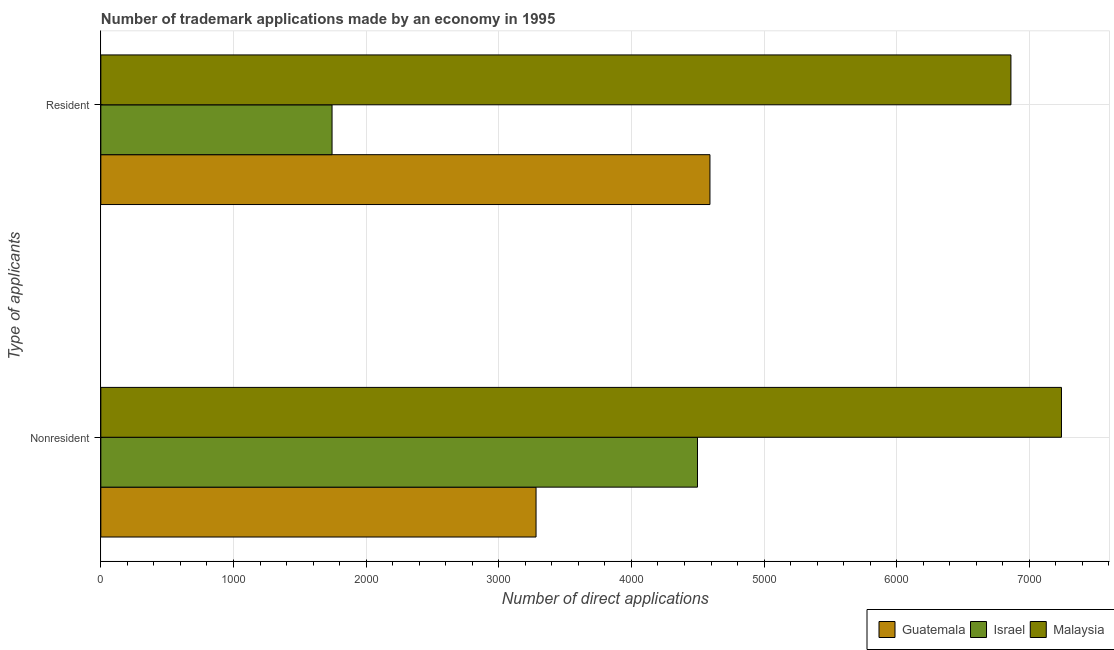Are the number of bars on each tick of the Y-axis equal?
Provide a short and direct response. Yes. How many bars are there on the 1st tick from the bottom?
Ensure brevity in your answer.  3. What is the label of the 1st group of bars from the top?
Provide a succinct answer. Resident. What is the number of trademark applications made by non residents in Malaysia?
Your response must be concise. 7242. Across all countries, what is the maximum number of trademark applications made by non residents?
Your answer should be compact. 7242. Across all countries, what is the minimum number of trademark applications made by residents?
Make the answer very short. 1743. In which country was the number of trademark applications made by residents maximum?
Give a very brief answer. Malaysia. In which country was the number of trademark applications made by residents minimum?
Give a very brief answer. Israel. What is the total number of trademark applications made by residents in the graph?
Your answer should be very brief. 1.32e+04. What is the difference between the number of trademark applications made by non residents in Israel and that in Malaysia?
Offer a terse response. -2744. What is the difference between the number of trademark applications made by residents in Guatemala and the number of trademark applications made by non residents in Israel?
Keep it short and to the point. 94. What is the average number of trademark applications made by non residents per country?
Your response must be concise. 5007. What is the difference between the number of trademark applications made by residents and number of trademark applications made by non residents in Israel?
Provide a short and direct response. -2755. What is the ratio of the number of trademark applications made by non residents in Guatemala to that in Malaysia?
Provide a short and direct response. 0.45. What does the 2nd bar from the bottom in Resident represents?
Keep it short and to the point. Israel. Are all the bars in the graph horizontal?
Your response must be concise. Yes. Are the values on the major ticks of X-axis written in scientific E-notation?
Keep it short and to the point. No. Where does the legend appear in the graph?
Keep it short and to the point. Bottom right. How are the legend labels stacked?
Your response must be concise. Horizontal. What is the title of the graph?
Give a very brief answer. Number of trademark applications made by an economy in 1995. Does "Sub-Saharan Africa (all income levels)" appear as one of the legend labels in the graph?
Make the answer very short. No. What is the label or title of the X-axis?
Ensure brevity in your answer.  Number of direct applications. What is the label or title of the Y-axis?
Ensure brevity in your answer.  Type of applicants. What is the Number of direct applications of Guatemala in Nonresident?
Your answer should be very brief. 3281. What is the Number of direct applications in Israel in Nonresident?
Offer a very short reply. 4498. What is the Number of direct applications in Malaysia in Nonresident?
Provide a short and direct response. 7242. What is the Number of direct applications in Guatemala in Resident?
Provide a succinct answer. 4592. What is the Number of direct applications of Israel in Resident?
Offer a very short reply. 1743. What is the Number of direct applications in Malaysia in Resident?
Keep it short and to the point. 6861. Across all Type of applicants, what is the maximum Number of direct applications of Guatemala?
Provide a short and direct response. 4592. Across all Type of applicants, what is the maximum Number of direct applications in Israel?
Your response must be concise. 4498. Across all Type of applicants, what is the maximum Number of direct applications in Malaysia?
Provide a short and direct response. 7242. Across all Type of applicants, what is the minimum Number of direct applications of Guatemala?
Make the answer very short. 3281. Across all Type of applicants, what is the minimum Number of direct applications in Israel?
Offer a terse response. 1743. Across all Type of applicants, what is the minimum Number of direct applications in Malaysia?
Your response must be concise. 6861. What is the total Number of direct applications in Guatemala in the graph?
Your answer should be very brief. 7873. What is the total Number of direct applications of Israel in the graph?
Make the answer very short. 6241. What is the total Number of direct applications in Malaysia in the graph?
Make the answer very short. 1.41e+04. What is the difference between the Number of direct applications of Guatemala in Nonresident and that in Resident?
Provide a succinct answer. -1311. What is the difference between the Number of direct applications of Israel in Nonresident and that in Resident?
Give a very brief answer. 2755. What is the difference between the Number of direct applications in Malaysia in Nonresident and that in Resident?
Give a very brief answer. 381. What is the difference between the Number of direct applications of Guatemala in Nonresident and the Number of direct applications of Israel in Resident?
Provide a short and direct response. 1538. What is the difference between the Number of direct applications of Guatemala in Nonresident and the Number of direct applications of Malaysia in Resident?
Your answer should be compact. -3580. What is the difference between the Number of direct applications in Israel in Nonresident and the Number of direct applications in Malaysia in Resident?
Your answer should be very brief. -2363. What is the average Number of direct applications in Guatemala per Type of applicants?
Provide a short and direct response. 3936.5. What is the average Number of direct applications in Israel per Type of applicants?
Offer a terse response. 3120.5. What is the average Number of direct applications of Malaysia per Type of applicants?
Make the answer very short. 7051.5. What is the difference between the Number of direct applications of Guatemala and Number of direct applications of Israel in Nonresident?
Provide a short and direct response. -1217. What is the difference between the Number of direct applications of Guatemala and Number of direct applications of Malaysia in Nonresident?
Make the answer very short. -3961. What is the difference between the Number of direct applications in Israel and Number of direct applications in Malaysia in Nonresident?
Make the answer very short. -2744. What is the difference between the Number of direct applications of Guatemala and Number of direct applications of Israel in Resident?
Keep it short and to the point. 2849. What is the difference between the Number of direct applications in Guatemala and Number of direct applications in Malaysia in Resident?
Ensure brevity in your answer.  -2269. What is the difference between the Number of direct applications of Israel and Number of direct applications of Malaysia in Resident?
Your answer should be very brief. -5118. What is the ratio of the Number of direct applications in Guatemala in Nonresident to that in Resident?
Your answer should be very brief. 0.71. What is the ratio of the Number of direct applications of Israel in Nonresident to that in Resident?
Provide a succinct answer. 2.58. What is the ratio of the Number of direct applications of Malaysia in Nonresident to that in Resident?
Offer a terse response. 1.06. What is the difference between the highest and the second highest Number of direct applications in Guatemala?
Your answer should be very brief. 1311. What is the difference between the highest and the second highest Number of direct applications of Israel?
Your answer should be very brief. 2755. What is the difference between the highest and the second highest Number of direct applications in Malaysia?
Provide a short and direct response. 381. What is the difference between the highest and the lowest Number of direct applications of Guatemala?
Provide a short and direct response. 1311. What is the difference between the highest and the lowest Number of direct applications of Israel?
Offer a terse response. 2755. What is the difference between the highest and the lowest Number of direct applications of Malaysia?
Give a very brief answer. 381. 